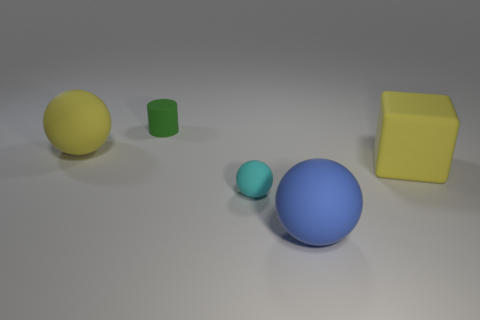What number of other objects are there of the same material as the large blue ball?
Provide a short and direct response. 4. How many small things are yellow matte spheres or green rubber cubes?
Provide a succinct answer. 0. Are there the same number of balls that are behind the blue sphere and big yellow objects?
Keep it short and to the point. Yes. Are there any yellow rubber objects that are on the right side of the large sphere that is behind the big blue object?
Provide a succinct answer. Yes. What number of other things are there of the same color as the tiny rubber ball?
Your response must be concise. 0. What is the color of the cylinder?
Provide a short and direct response. Green. What size is the rubber thing that is both on the right side of the cyan matte object and left of the large rubber block?
Your answer should be compact. Large. How many things are yellow rubber things to the left of the small ball or tiny brown metallic balls?
Offer a very short reply. 1. What is the shape of the small cyan thing that is the same material as the large blue thing?
Ensure brevity in your answer.  Sphere. There is a tiny green object; what shape is it?
Provide a succinct answer. Cylinder. 